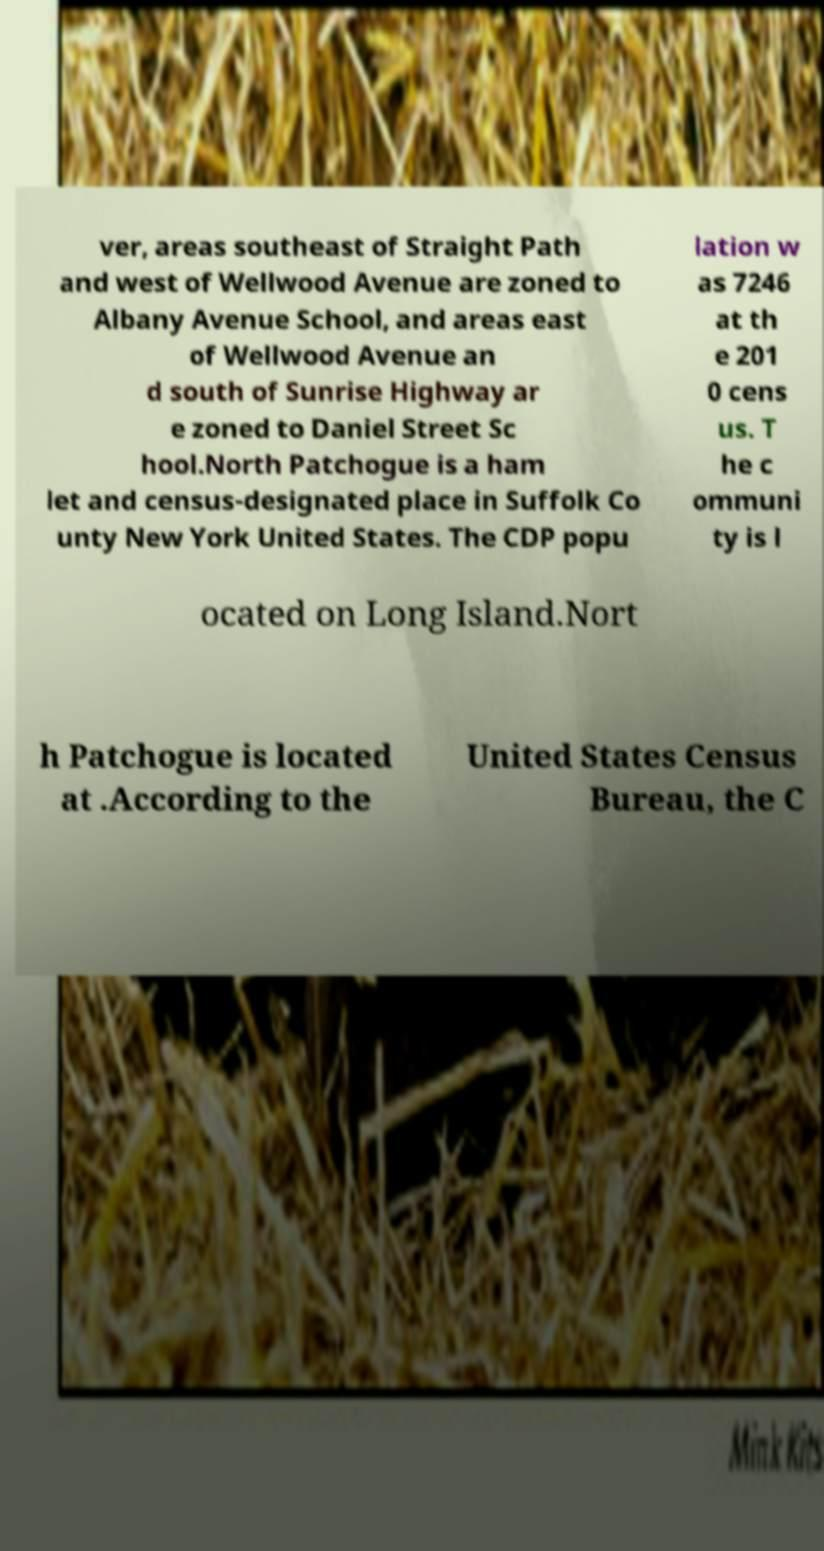Please read and relay the text visible in this image. What does it say? ver, areas southeast of Straight Path and west of Wellwood Avenue are zoned to Albany Avenue School, and areas east of Wellwood Avenue an d south of Sunrise Highway ar e zoned to Daniel Street Sc hool.North Patchogue is a ham let and census-designated place in Suffolk Co unty New York United States. The CDP popu lation w as 7246 at th e 201 0 cens us. T he c ommuni ty is l ocated on Long Island.Nort h Patchogue is located at .According to the United States Census Bureau, the C 